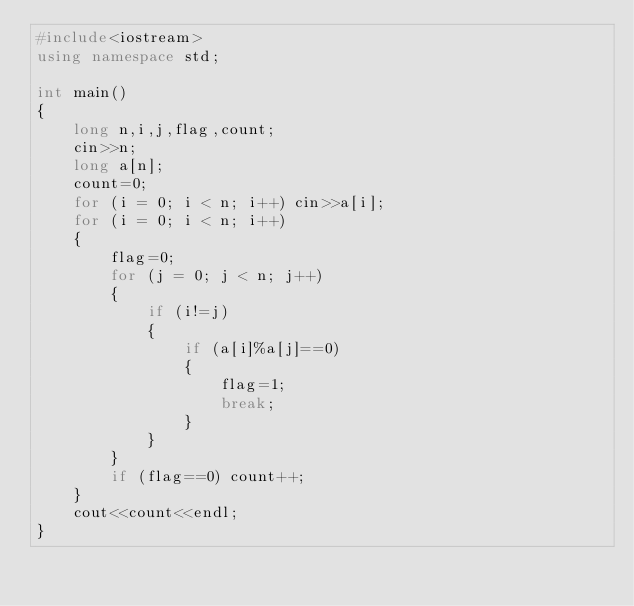Convert code to text. <code><loc_0><loc_0><loc_500><loc_500><_C++_>#include<iostream>
using namespace std;

int main()
{
    long n,i,j,flag,count;
    cin>>n;
    long a[n];
    count=0;
    for (i = 0; i < n; i++) cin>>a[i];
    for (i = 0; i < n; i++)
    {
        flag=0;
        for (j = 0; j < n; j++)
        {
            if (i!=j)
            {
                if (a[i]%a[j]==0)
                {
                    flag=1;
                    break;
                }
            }
        }
        if (flag==0) count++;
    }
    cout<<count<<endl;
}</code> 